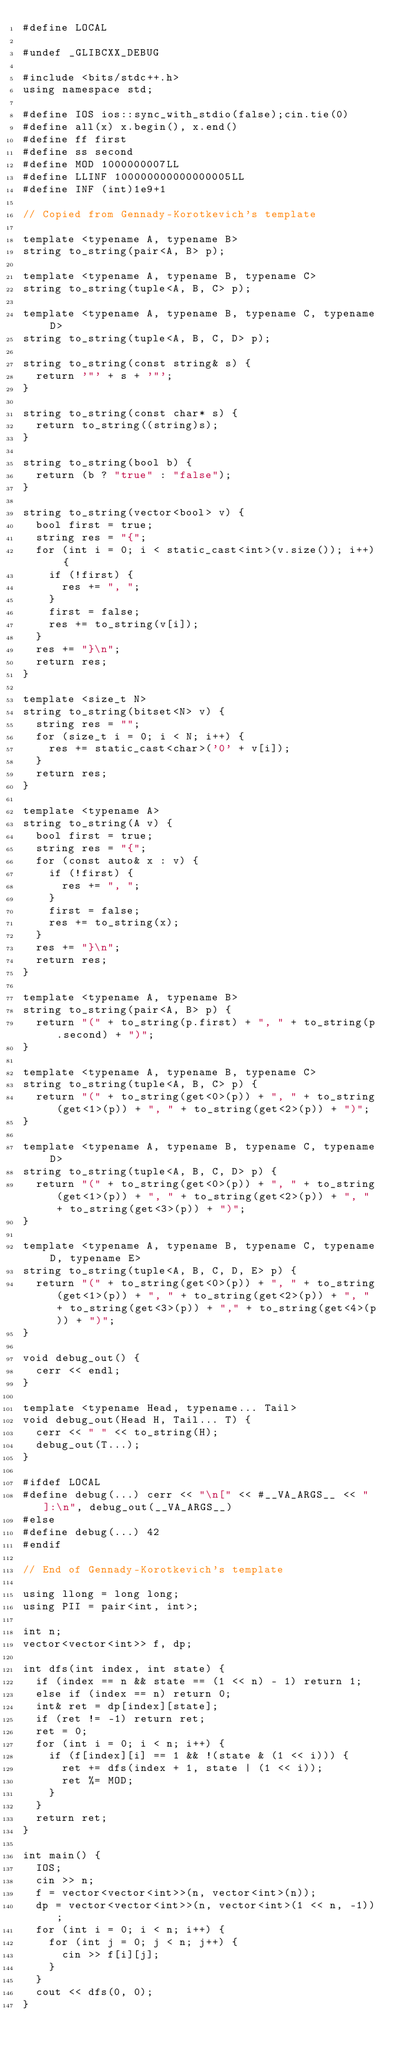<code> <loc_0><loc_0><loc_500><loc_500><_C++_>#define LOCAL

#undef _GLIBCXX_DEBUG

#include <bits/stdc++.h>
using namespace std;

#define IOS ios::sync_with_stdio(false);cin.tie(0)
#define all(x) x.begin(), x.end()
#define ff first
#define ss second
#define MOD 1000000007LL
#define LLINF 100000000000000005LL
#define INF (int)1e9+1

// Copied from Gennady-Korotkevich's template

template <typename A, typename B>
string to_string(pair<A, B> p);

template <typename A, typename B, typename C>
string to_string(tuple<A, B, C> p);

template <typename A, typename B, typename C, typename D>
string to_string(tuple<A, B, C, D> p);

string to_string(const string& s) {
	return '"' + s + '"';
}

string to_string(const char* s) {
	return to_string((string)s);
}

string to_string(bool b) {
	return (b ? "true" : "false");
}

string to_string(vector<bool> v) {
	bool first = true;
	string res = "{";
	for (int i = 0; i < static_cast<int>(v.size()); i++) {
		if (!first) {
			res += ", ";
		}
		first = false;
		res += to_string(v[i]);
	}
	res += "}\n";
	return res;
}

template <size_t N>
string to_string(bitset<N> v) {
	string res = "";
	for (size_t i = 0; i < N; i++) {
		res += static_cast<char>('0' + v[i]);
	}
	return res;
}

template <typename A>
string to_string(A v) {
	bool first = true;
	string res = "{";
	for (const auto& x : v) {
		if (!first) {
			res += ", ";
		}
		first = false;
		res += to_string(x);
	}
	res += "}\n";
	return res;
}

template <typename A, typename B>
string to_string(pair<A, B> p) {
	return "(" + to_string(p.first) + ", " + to_string(p.second) + ")";
}

template <typename A, typename B, typename C>
string to_string(tuple<A, B, C> p) {
	return "(" + to_string(get<0>(p)) + ", " + to_string(get<1>(p)) + ", " + to_string(get<2>(p)) + ")";
}

template <typename A, typename B, typename C, typename D>
string to_string(tuple<A, B, C, D> p) {
	return "(" + to_string(get<0>(p)) + ", " + to_string(get<1>(p)) + ", " + to_string(get<2>(p)) + ", " + to_string(get<3>(p)) + ")";
}

template <typename A, typename B, typename C, typename D, typename E>
string to_string(tuple<A, B, C, D, E> p) {
	return "(" + to_string(get<0>(p)) + ", " + to_string(get<1>(p)) + ", " + to_string(get<2>(p)) + ", " + to_string(get<3>(p)) + "," + to_string(get<4>(p)) + ")";
}

void debug_out() {
	cerr << endl;
}

template <typename Head, typename... Tail>
void debug_out(Head H, Tail... T) {
	cerr << " " << to_string(H);
	debug_out(T...);
}

#ifdef LOCAL
#define debug(...) cerr << "\n[" << #__VA_ARGS__ << "]:\n", debug_out(__VA_ARGS__)
#else
#define debug(...) 42
#endif

// End of Gennady-Korotkevich's template 

using llong = long long;
using PII = pair<int, int>;

int n;
vector<vector<int>> f, dp;

int dfs(int index, int state) {
	if (index == n && state == (1 << n) - 1) return 1;
	else if (index == n) return 0;
	int& ret = dp[index][state];
	if (ret != -1) return ret;
	ret = 0;
	for (int i = 0; i < n; i++) {
		if (f[index][i] == 1 && !(state & (1 << i))) {
			ret += dfs(index + 1, state | (1 << i));
			ret %= MOD;
		}
	}
	return ret;
}

int main() {
	IOS;
	cin >> n;
	f = vector<vector<int>>(n, vector<int>(n));
	dp = vector<vector<int>>(n, vector<int>(1 << n, -1));
	for (int i = 0; i < n; i++) {
		for (int j = 0; j < n; j++) {
			cin >> f[i][j];
		}
	}
	cout << dfs(0, 0);
}</code> 